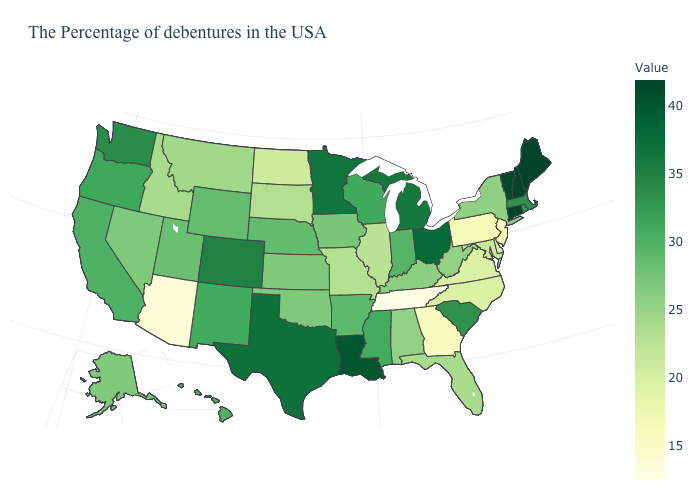Which states hav the highest value in the MidWest?
Write a very short answer. Ohio. Which states have the highest value in the USA?
Keep it brief. Maine, New Hampshire, Connecticut. Among the states that border Louisiana , which have the lowest value?
Write a very short answer. Arkansas. Does New Jersey have the highest value in the Northeast?
Concise answer only. No. 